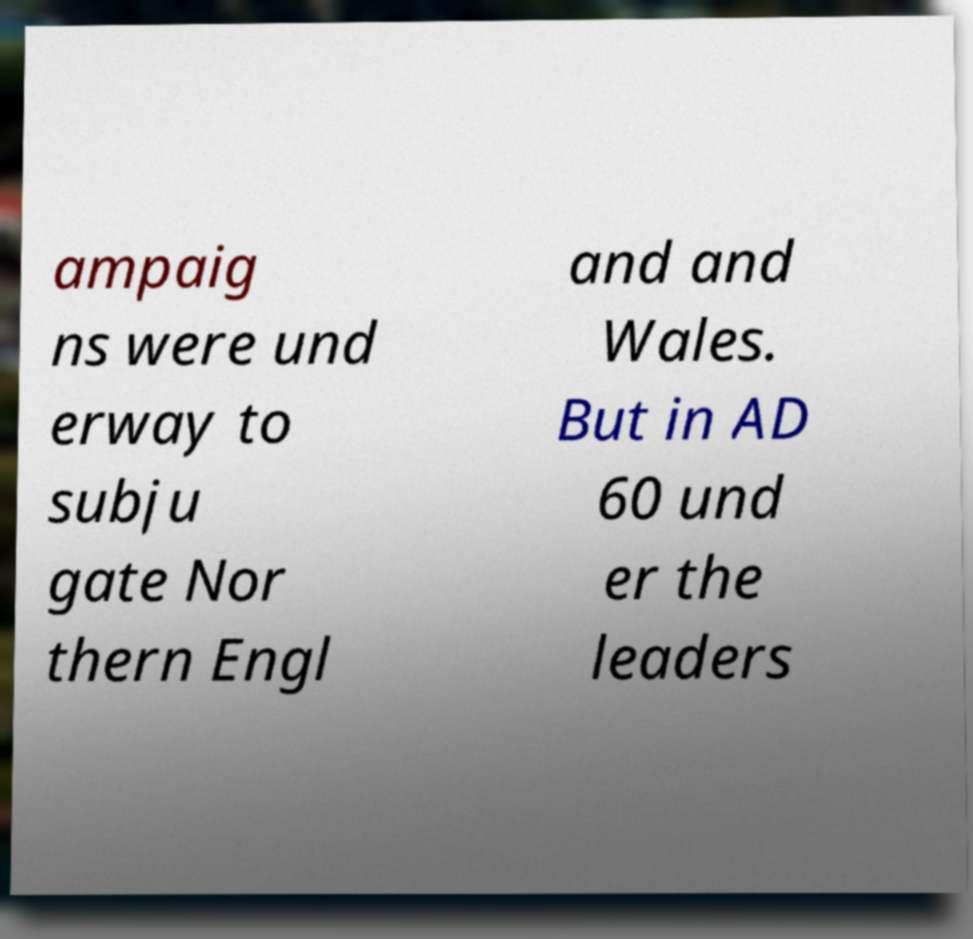Could you extract and type out the text from this image? ampaig ns were und erway to subju gate Nor thern Engl and and Wales. But in AD 60 und er the leaders 